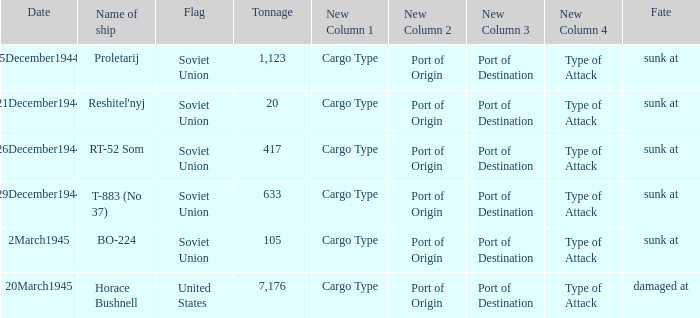How did the ship named proletarij finish its service? Sunk at. 